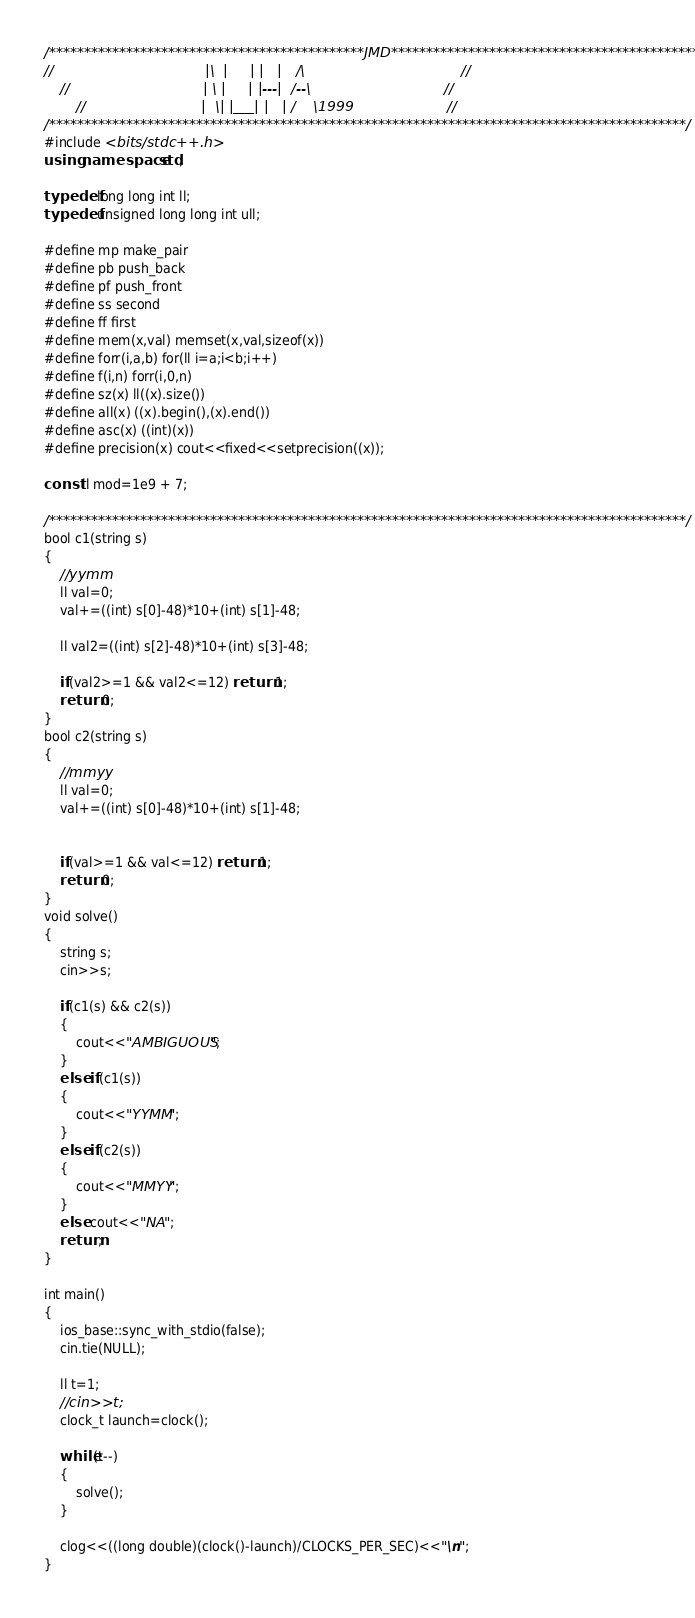<code> <loc_0><loc_0><loc_500><loc_500><_C++_>/*********************************************JMD**********************************************/
//                                  |\  |     | |   |   /\                                   //
    //                              | \ |     | |---|  /--\                              //
        //                          |  \| |___| |   | /    \1999                     //
/*******************************************************************************************/
#include <bits/stdc++.h>
using namespace std;

typedef long long int ll;
typedef unsigned long long int ull;

#define mp make_pair
#define pb push_back
#define pf push_front
#define ss second
#define ff first
#define mem(x,val) memset(x,val,sizeof(x))
#define forr(i,a,b) for(ll i=a;i<b;i++)
#define f(i,n) forr(i,0,n)
#define sz(x) ll((x).size())
#define all(x) ((x).begin(),(x).end())
#define asc(x) ((int)(x))
#define precision(x) cout<<fixed<<setprecision((x));

const ll mod=1e9 + 7;

/*******************************************************************************************/
bool c1(string s)
{
    //yymm
    ll val=0;
    val+=((int) s[0]-48)*10+(int) s[1]-48;

    ll val2=((int) s[2]-48)*10+(int) s[3]-48;

    if(val2>=1 && val2<=12) return 1;
    return 0;
}
bool c2(string s)
{
    //mmyy
    ll val=0;
    val+=((int) s[0]-48)*10+(int) s[1]-48;


    if(val>=1 && val<=12) return 1;
    return 0;
}
void solve()
{
    string s;
    cin>>s;

    if(c1(s) && c2(s))
    {
        cout<<"AMBIGUOUS";
    }
    else if(c1(s))
    {
        cout<<"YYMM";
    }
    else if(c2(s))
    {
        cout<<"MMYY";
    }
    else cout<<"NA";
    return;
}

int main()
{
    ios_base::sync_with_stdio(false);
    cin.tie(NULL);

    ll t=1;
    //cin>>t;
    clock_t launch=clock();

    while(t--)
    {
        solve();
    }

    clog<<((long double)(clock()-launch)/CLOCKS_PER_SEC)<<"\n";
}
</code> 